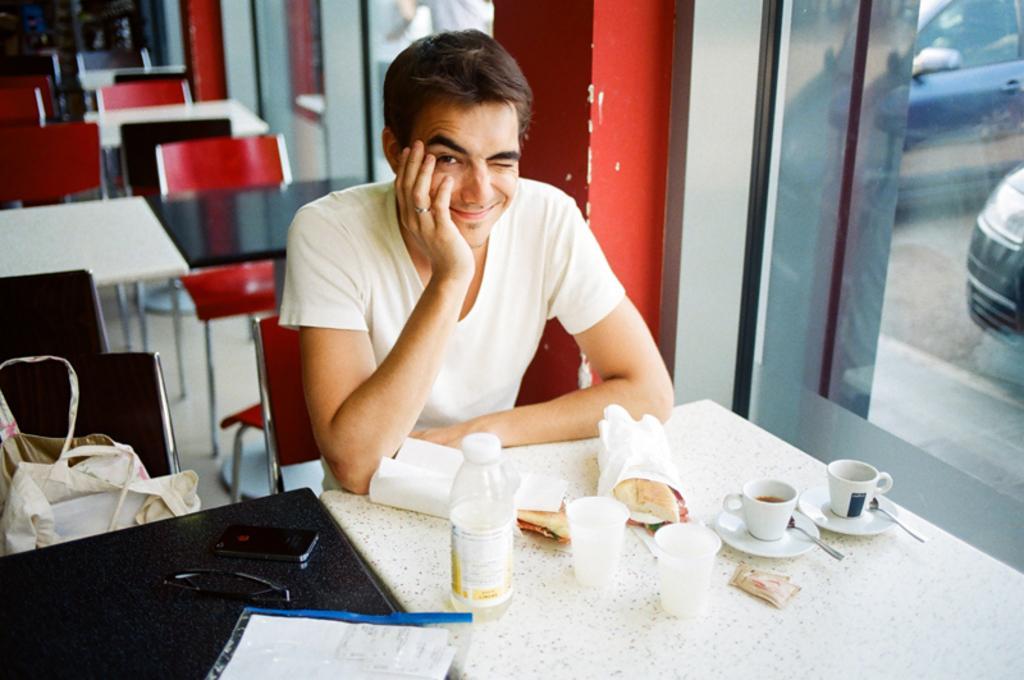Can you describe this image briefly? On the background we can see empty chairs and tables. We can see one man wearing white colour tshirt and he is winking his eye and smiling , sitting on a chair in front of a table and on the table we can see food, cups and saucers, spoon, bottles and a paper. Beside to him there is a chair and on the chair we can see a handbag. Through window glass we can see cars. 